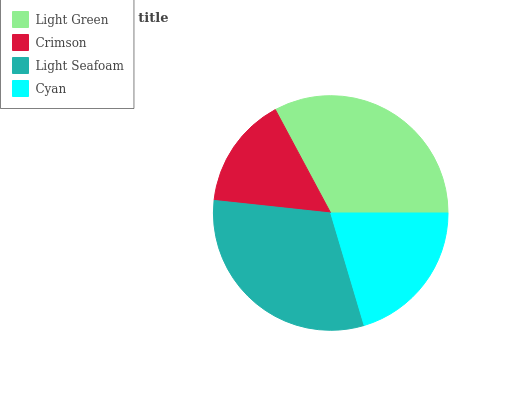Is Crimson the minimum?
Answer yes or no. Yes. Is Light Green the maximum?
Answer yes or no. Yes. Is Light Seafoam the minimum?
Answer yes or no. No. Is Light Seafoam the maximum?
Answer yes or no. No. Is Light Seafoam greater than Crimson?
Answer yes or no. Yes. Is Crimson less than Light Seafoam?
Answer yes or no. Yes. Is Crimson greater than Light Seafoam?
Answer yes or no. No. Is Light Seafoam less than Crimson?
Answer yes or no. No. Is Light Seafoam the high median?
Answer yes or no. Yes. Is Cyan the low median?
Answer yes or no. Yes. Is Light Green the high median?
Answer yes or no. No. Is Crimson the low median?
Answer yes or no. No. 